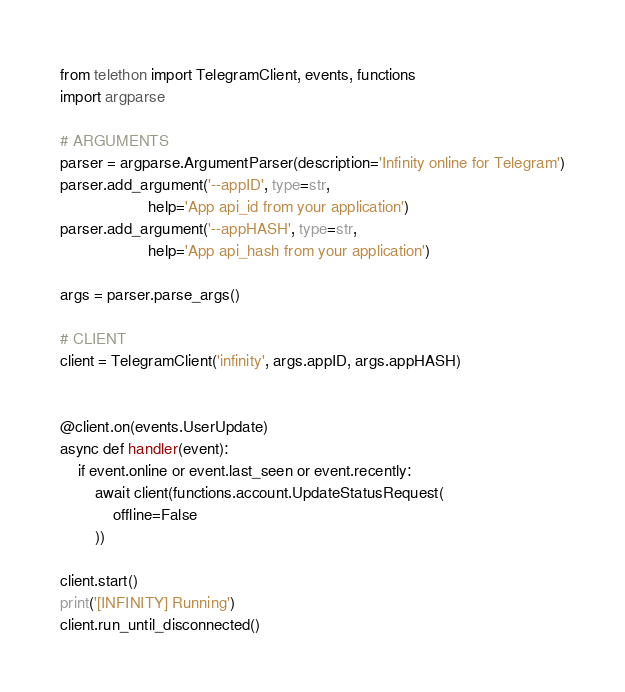<code> <loc_0><loc_0><loc_500><loc_500><_Python_>from telethon import TelegramClient, events, functions
import argparse

# ARGUMENTS
parser = argparse.ArgumentParser(description='Infinity online for Telegram')
parser.add_argument('--appID', type=str,
                    help='App api_id from your application')
parser.add_argument('--appHASH', type=str,
                    help='App api_hash from your application')

args = parser.parse_args()

# CLIENT
client = TelegramClient('infinity', args.appID, args.appHASH)


@client.on(events.UserUpdate)
async def handler(event):
    if event.online or event.last_seen or event.recently:
        await client(functions.account.UpdateStatusRequest(
            offline=False
        ))

client.start()
print('[INFINITY] Running')
client.run_until_disconnected()
</code> 